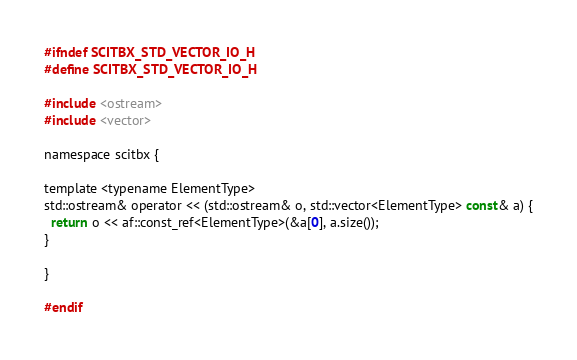<code> <loc_0><loc_0><loc_500><loc_500><_C_>#ifndef SCITBX_STD_VECTOR_IO_H
#define SCITBX_STD_VECTOR_IO_H

#include <ostream>
#include <vector>

namespace scitbx {

template <typename ElementType>
std::ostream& operator << (std::ostream& o, std::vector<ElementType> const& a) {
  return o << af::const_ref<ElementType>(&a[0], a.size());
}

}

#endif
</code> 